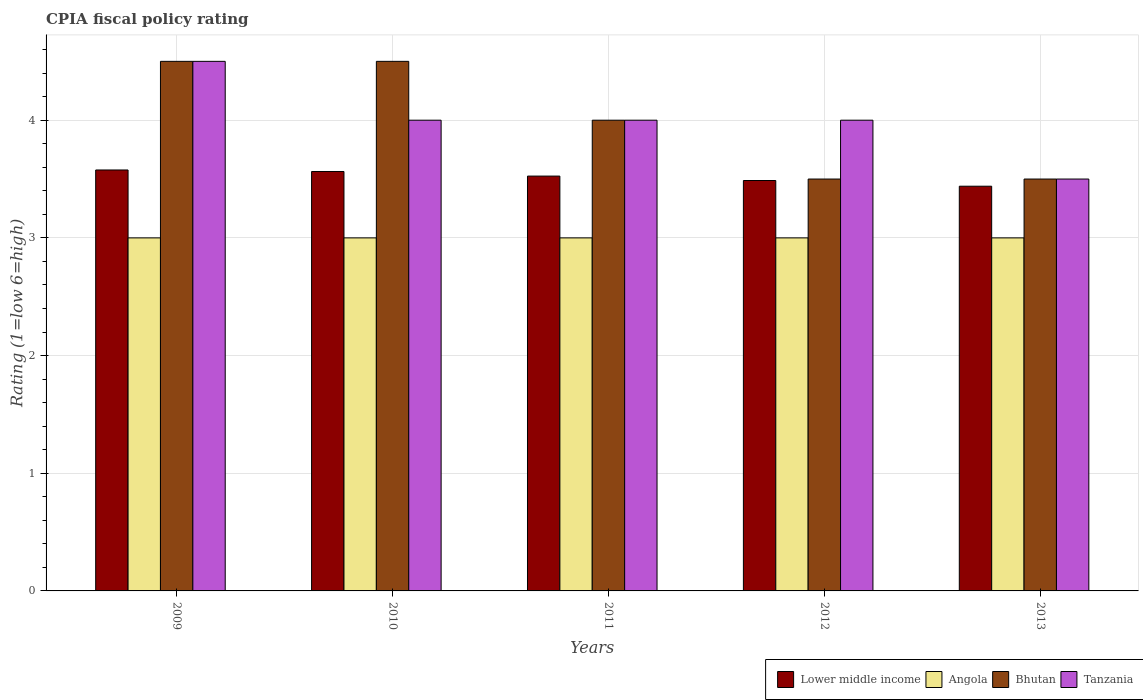Are the number of bars per tick equal to the number of legend labels?
Give a very brief answer. Yes. Are the number of bars on each tick of the X-axis equal?
Make the answer very short. Yes. How many bars are there on the 2nd tick from the right?
Offer a very short reply. 4. What is the label of the 2nd group of bars from the left?
Give a very brief answer. 2010. Across all years, what is the minimum CPIA rating in Lower middle income?
Give a very brief answer. 3.44. In which year was the CPIA rating in Angola maximum?
Offer a very short reply. 2009. What is the difference between the CPIA rating in Bhutan in 2009 and that in 2012?
Give a very brief answer. 1. What is the average CPIA rating in Bhutan per year?
Make the answer very short. 4. In the year 2013, what is the difference between the CPIA rating in Lower middle income and CPIA rating in Angola?
Your answer should be compact. 0.44. In how many years, is the CPIA rating in Angola greater than 1?
Ensure brevity in your answer.  5. Is the CPIA rating in Bhutan in 2009 less than that in 2012?
Provide a short and direct response. No. Is the difference between the CPIA rating in Lower middle income in 2010 and 2012 greater than the difference between the CPIA rating in Angola in 2010 and 2012?
Make the answer very short. Yes. What is the difference between the highest and the lowest CPIA rating in Angola?
Your response must be concise. 0. In how many years, is the CPIA rating in Lower middle income greater than the average CPIA rating in Lower middle income taken over all years?
Provide a succinct answer. 3. Is the sum of the CPIA rating in Tanzania in 2010 and 2013 greater than the maximum CPIA rating in Angola across all years?
Your answer should be compact. Yes. What does the 2nd bar from the left in 2012 represents?
Your answer should be very brief. Angola. What does the 2nd bar from the right in 2013 represents?
Provide a succinct answer. Bhutan. How many bars are there?
Keep it short and to the point. 20. How many years are there in the graph?
Offer a very short reply. 5. Are the values on the major ticks of Y-axis written in scientific E-notation?
Provide a short and direct response. No. Does the graph contain any zero values?
Ensure brevity in your answer.  No. Does the graph contain grids?
Give a very brief answer. Yes. Where does the legend appear in the graph?
Keep it short and to the point. Bottom right. How are the legend labels stacked?
Ensure brevity in your answer.  Horizontal. What is the title of the graph?
Your response must be concise. CPIA fiscal policy rating. What is the label or title of the X-axis?
Ensure brevity in your answer.  Years. What is the Rating (1=low 6=high) of Lower middle income in 2009?
Your answer should be very brief. 3.58. What is the Rating (1=low 6=high) in Angola in 2009?
Keep it short and to the point. 3. What is the Rating (1=low 6=high) of Bhutan in 2009?
Offer a very short reply. 4.5. What is the Rating (1=low 6=high) of Lower middle income in 2010?
Provide a short and direct response. 3.56. What is the Rating (1=low 6=high) of Angola in 2010?
Your answer should be compact. 3. What is the Rating (1=low 6=high) in Tanzania in 2010?
Provide a short and direct response. 4. What is the Rating (1=low 6=high) of Lower middle income in 2011?
Give a very brief answer. 3.52. What is the Rating (1=low 6=high) in Bhutan in 2011?
Provide a short and direct response. 4. What is the Rating (1=low 6=high) of Tanzania in 2011?
Provide a succinct answer. 4. What is the Rating (1=low 6=high) in Lower middle income in 2012?
Provide a succinct answer. 3.49. What is the Rating (1=low 6=high) in Bhutan in 2012?
Your answer should be very brief. 3.5. What is the Rating (1=low 6=high) in Lower middle income in 2013?
Provide a short and direct response. 3.44. What is the Rating (1=low 6=high) of Angola in 2013?
Provide a succinct answer. 3. What is the Rating (1=low 6=high) in Bhutan in 2013?
Your answer should be very brief. 3.5. Across all years, what is the maximum Rating (1=low 6=high) in Lower middle income?
Your answer should be very brief. 3.58. Across all years, what is the minimum Rating (1=low 6=high) in Lower middle income?
Offer a terse response. 3.44. Across all years, what is the minimum Rating (1=low 6=high) in Angola?
Your response must be concise. 3. Across all years, what is the minimum Rating (1=low 6=high) in Bhutan?
Ensure brevity in your answer.  3.5. What is the total Rating (1=low 6=high) of Lower middle income in the graph?
Your answer should be very brief. 17.59. What is the total Rating (1=low 6=high) of Bhutan in the graph?
Your answer should be very brief. 20. What is the total Rating (1=low 6=high) of Tanzania in the graph?
Your response must be concise. 20. What is the difference between the Rating (1=low 6=high) in Lower middle income in 2009 and that in 2010?
Your answer should be compact. 0.01. What is the difference between the Rating (1=low 6=high) in Angola in 2009 and that in 2010?
Ensure brevity in your answer.  0. What is the difference between the Rating (1=low 6=high) in Tanzania in 2009 and that in 2010?
Ensure brevity in your answer.  0.5. What is the difference between the Rating (1=low 6=high) in Lower middle income in 2009 and that in 2011?
Ensure brevity in your answer.  0.05. What is the difference between the Rating (1=low 6=high) of Angola in 2009 and that in 2011?
Your answer should be compact. 0. What is the difference between the Rating (1=low 6=high) of Tanzania in 2009 and that in 2011?
Provide a succinct answer. 0.5. What is the difference between the Rating (1=low 6=high) of Lower middle income in 2009 and that in 2012?
Ensure brevity in your answer.  0.09. What is the difference between the Rating (1=low 6=high) of Angola in 2009 and that in 2012?
Offer a very short reply. 0. What is the difference between the Rating (1=low 6=high) in Lower middle income in 2009 and that in 2013?
Provide a succinct answer. 0.14. What is the difference between the Rating (1=low 6=high) in Angola in 2009 and that in 2013?
Keep it short and to the point. 0. What is the difference between the Rating (1=low 6=high) in Bhutan in 2009 and that in 2013?
Give a very brief answer. 1. What is the difference between the Rating (1=low 6=high) in Lower middle income in 2010 and that in 2011?
Give a very brief answer. 0.04. What is the difference between the Rating (1=low 6=high) of Lower middle income in 2010 and that in 2012?
Offer a terse response. 0.08. What is the difference between the Rating (1=low 6=high) in Angola in 2010 and that in 2012?
Your response must be concise. 0. What is the difference between the Rating (1=low 6=high) of Bhutan in 2010 and that in 2012?
Provide a succinct answer. 1. What is the difference between the Rating (1=low 6=high) of Lower middle income in 2010 and that in 2013?
Offer a very short reply. 0.13. What is the difference between the Rating (1=low 6=high) in Angola in 2010 and that in 2013?
Make the answer very short. 0. What is the difference between the Rating (1=low 6=high) of Bhutan in 2010 and that in 2013?
Your answer should be compact. 1. What is the difference between the Rating (1=low 6=high) of Lower middle income in 2011 and that in 2012?
Your response must be concise. 0.04. What is the difference between the Rating (1=low 6=high) of Bhutan in 2011 and that in 2012?
Your answer should be very brief. 0.5. What is the difference between the Rating (1=low 6=high) in Tanzania in 2011 and that in 2012?
Your answer should be very brief. 0. What is the difference between the Rating (1=low 6=high) in Lower middle income in 2011 and that in 2013?
Give a very brief answer. 0.09. What is the difference between the Rating (1=low 6=high) of Angola in 2011 and that in 2013?
Keep it short and to the point. 0. What is the difference between the Rating (1=low 6=high) in Bhutan in 2011 and that in 2013?
Give a very brief answer. 0.5. What is the difference between the Rating (1=low 6=high) in Tanzania in 2011 and that in 2013?
Offer a terse response. 0.5. What is the difference between the Rating (1=low 6=high) of Lower middle income in 2012 and that in 2013?
Make the answer very short. 0.05. What is the difference between the Rating (1=low 6=high) of Bhutan in 2012 and that in 2013?
Provide a succinct answer. 0. What is the difference between the Rating (1=low 6=high) of Lower middle income in 2009 and the Rating (1=low 6=high) of Angola in 2010?
Provide a succinct answer. 0.58. What is the difference between the Rating (1=low 6=high) in Lower middle income in 2009 and the Rating (1=low 6=high) in Bhutan in 2010?
Offer a terse response. -0.92. What is the difference between the Rating (1=low 6=high) of Lower middle income in 2009 and the Rating (1=low 6=high) of Tanzania in 2010?
Ensure brevity in your answer.  -0.42. What is the difference between the Rating (1=low 6=high) in Angola in 2009 and the Rating (1=low 6=high) in Tanzania in 2010?
Offer a very short reply. -1. What is the difference between the Rating (1=low 6=high) in Bhutan in 2009 and the Rating (1=low 6=high) in Tanzania in 2010?
Your answer should be compact. 0.5. What is the difference between the Rating (1=low 6=high) of Lower middle income in 2009 and the Rating (1=low 6=high) of Angola in 2011?
Make the answer very short. 0.58. What is the difference between the Rating (1=low 6=high) of Lower middle income in 2009 and the Rating (1=low 6=high) of Bhutan in 2011?
Provide a short and direct response. -0.42. What is the difference between the Rating (1=low 6=high) of Lower middle income in 2009 and the Rating (1=low 6=high) of Tanzania in 2011?
Offer a terse response. -0.42. What is the difference between the Rating (1=low 6=high) in Angola in 2009 and the Rating (1=low 6=high) in Bhutan in 2011?
Give a very brief answer. -1. What is the difference between the Rating (1=low 6=high) of Angola in 2009 and the Rating (1=low 6=high) of Tanzania in 2011?
Offer a terse response. -1. What is the difference between the Rating (1=low 6=high) in Lower middle income in 2009 and the Rating (1=low 6=high) in Angola in 2012?
Your answer should be compact. 0.58. What is the difference between the Rating (1=low 6=high) of Lower middle income in 2009 and the Rating (1=low 6=high) of Bhutan in 2012?
Your answer should be compact. 0.08. What is the difference between the Rating (1=low 6=high) of Lower middle income in 2009 and the Rating (1=low 6=high) of Tanzania in 2012?
Your response must be concise. -0.42. What is the difference between the Rating (1=low 6=high) of Angola in 2009 and the Rating (1=low 6=high) of Bhutan in 2012?
Give a very brief answer. -0.5. What is the difference between the Rating (1=low 6=high) of Bhutan in 2009 and the Rating (1=low 6=high) of Tanzania in 2012?
Your answer should be compact. 0.5. What is the difference between the Rating (1=low 6=high) in Lower middle income in 2009 and the Rating (1=low 6=high) in Angola in 2013?
Provide a succinct answer. 0.58. What is the difference between the Rating (1=low 6=high) in Lower middle income in 2009 and the Rating (1=low 6=high) in Bhutan in 2013?
Give a very brief answer. 0.08. What is the difference between the Rating (1=low 6=high) in Lower middle income in 2009 and the Rating (1=low 6=high) in Tanzania in 2013?
Ensure brevity in your answer.  0.08. What is the difference between the Rating (1=low 6=high) of Angola in 2009 and the Rating (1=low 6=high) of Bhutan in 2013?
Make the answer very short. -0.5. What is the difference between the Rating (1=low 6=high) of Bhutan in 2009 and the Rating (1=low 6=high) of Tanzania in 2013?
Make the answer very short. 1. What is the difference between the Rating (1=low 6=high) in Lower middle income in 2010 and the Rating (1=low 6=high) in Angola in 2011?
Provide a short and direct response. 0.56. What is the difference between the Rating (1=low 6=high) in Lower middle income in 2010 and the Rating (1=low 6=high) in Bhutan in 2011?
Ensure brevity in your answer.  -0.44. What is the difference between the Rating (1=low 6=high) in Lower middle income in 2010 and the Rating (1=low 6=high) in Tanzania in 2011?
Provide a succinct answer. -0.44. What is the difference between the Rating (1=low 6=high) of Lower middle income in 2010 and the Rating (1=low 6=high) of Angola in 2012?
Provide a short and direct response. 0.56. What is the difference between the Rating (1=low 6=high) of Lower middle income in 2010 and the Rating (1=low 6=high) of Bhutan in 2012?
Keep it short and to the point. 0.06. What is the difference between the Rating (1=low 6=high) of Lower middle income in 2010 and the Rating (1=low 6=high) of Tanzania in 2012?
Give a very brief answer. -0.44. What is the difference between the Rating (1=low 6=high) in Angola in 2010 and the Rating (1=low 6=high) in Bhutan in 2012?
Keep it short and to the point. -0.5. What is the difference between the Rating (1=low 6=high) in Angola in 2010 and the Rating (1=low 6=high) in Tanzania in 2012?
Offer a very short reply. -1. What is the difference between the Rating (1=low 6=high) in Lower middle income in 2010 and the Rating (1=low 6=high) in Angola in 2013?
Your answer should be compact. 0.56. What is the difference between the Rating (1=low 6=high) in Lower middle income in 2010 and the Rating (1=low 6=high) in Bhutan in 2013?
Your answer should be compact. 0.06. What is the difference between the Rating (1=low 6=high) of Lower middle income in 2010 and the Rating (1=low 6=high) of Tanzania in 2013?
Give a very brief answer. 0.06. What is the difference between the Rating (1=low 6=high) of Bhutan in 2010 and the Rating (1=low 6=high) of Tanzania in 2013?
Ensure brevity in your answer.  1. What is the difference between the Rating (1=low 6=high) in Lower middle income in 2011 and the Rating (1=low 6=high) in Angola in 2012?
Make the answer very short. 0.53. What is the difference between the Rating (1=low 6=high) of Lower middle income in 2011 and the Rating (1=low 6=high) of Bhutan in 2012?
Your answer should be compact. 0.03. What is the difference between the Rating (1=low 6=high) of Lower middle income in 2011 and the Rating (1=low 6=high) of Tanzania in 2012?
Offer a terse response. -0.47. What is the difference between the Rating (1=low 6=high) of Angola in 2011 and the Rating (1=low 6=high) of Bhutan in 2012?
Provide a succinct answer. -0.5. What is the difference between the Rating (1=low 6=high) of Angola in 2011 and the Rating (1=low 6=high) of Tanzania in 2012?
Provide a succinct answer. -1. What is the difference between the Rating (1=low 6=high) in Bhutan in 2011 and the Rating (1=low 6=high) in Tanzania in 2012?
Ensure brevity in your answer.  0. What is the difference between the Rating (1=low 6=high) of Lower middle income in 2011 and the Rating (1=low 6=high) of Angola in 2013?
Ensure brevity in your answer.  0.53. What is the difference between the Rating (1=low 6=high) of Lower middle income in 2011 and the Rating (1=low 6=high) of Bhutan in 2013?
Offer a very short reply. 0.03. What is the difference between the Rating (1=low 6=high) of Lower middle income in 2011 and the Rating (1=low 6=high) of Tanzania in 2013?
Give a very brief answer. 0.03. What is the difference between the Rating (1=low 6=high) of Angola in 2011 and the Rating (1=low 6=high) of Bhutan in 2013?
Your response must be concise. -0.5. What is the difference between the Rating (1=low 6=high) of Angola in 2011 and the Rating (1=low 6=high) of Tanzania in 2013?
Give a very brief answer. -0.5. What is the difference between the Rating (1=low 6=high) of Bhutan in 2011 and the Rating (1=low 6=high) of Tanzania in 2013?
Give a very brief answer. 0.5. What is the difference between the Rating (1=low 6=high) of Lower middle income in 2012 and the Rating (1=low 6=high) of Angola in 2013?
Keep it short and to the point. 0.49. What is the difference between the Rating (1=low 6=high) of Lower middle income in 2012 and the Rating (1=low 6=high) of Bhutan in 2013?
Give a very brief answer. -0.01. What is the difference between the Rating (1=low 6=high) of Lower middle income in 2012 and the Rating (1=low 6=high) of Tanzania in 2013?
Your answer should be compact. -0.01. What is the difference between the Rating (1=low 6=high) in Angola in 2012 and the Rating (1=low 6=high) in Bhutan in 2013?
Provide a short and direct response. -0.5. What is the difference between the Rating (1=low 6=high) in Angola in 2012 and the Rating (1=low 6=high) in Tanzania in 2013?
Offer a very short reply. -0.5. What is the difference between the Rating (1=low 6=high) of Bhutan in 2012 and the Rating (1=low 6=high) of Tanzania in 2013?
Your answer should be very brief. 0. What is the average Rating (1=low 6=high) of Lower middle income per year?
Offer a terse response. 3.52. What is the average Rating (1=low 6=high) in Bhutan per year?
Your answer should be compact. 4. In the year 2009, what is the difference between the Rating (1=low 6=high) of Lower middle income and Rating (1=low 6=high) of Angola?
Give a very brief answer. 0.58. In the year 2009, what is the difference between the Rating (1=low 6=high) in Lower middle income and Rating (1=low 6=high) in Bhutan?
Your response must be concise. -0.92. In the year 2009, what is the difference between the Rating (1=low 6=high) in Lower middle income and Rating (1=low 6=high) in Tanzania?
Offer a terse response. -0.92. In the year 2009, what is the difference between the Rating (1=low 6=high) of Angola and Rating (1=low 6=high) of Tanzania?
Keep it short and to the point. -1.5. In the year 2009, what is the difference between the Rating (1=low 6=high) of Bhutan and Rating (1=low 6=high) of Tanzania?
Offer a very short reply. 0. In the year 2010, what is the difference between the Rating (1=low 6=high) of Lower middle income and Rating (1=low 6=high) of Angola?
Offer a terse response. 0.56. In the year 2010, what is the difference between the Rating (1=low 6=high) of Lower middle income and Rating (1=low 6=high) of Bhutan?
Keep it short and to the point. -0.94. In the year 2010, what is the difference between the Rating (1=low 6=high) of Lower middle income and Rating (1=low 6=high) of Tanzania?
Provide a short and direct response. -0.44. In the year 2011, what is the difference between the Rating (1=low 6=high) of Lower middle income and Rating (1=low 6=high) of Angola?
Your answer should be compact. 0.53. In the year 2011, what is the difference between the Rating (1=low 6=high) in Lower middle income and Rating (1=low 6=high) in Bhutan?
Offer a terse response. -0.47. In the year 2011, what is the difference between the Rating (1=low 6=high) of Lower middle income and Rating (1=low 6=high) of Tanzania?
Your response must be concise. -0.47. In the year 2011, what is the difference between the Rating (1=low 6=high) of Angola and Rating (1=low 6=high) of Bhutan?
Give a very brief answer. -1. In the year 2011, what is the difference between the Rating (1=low 6=high) of Bhutan and Rating (1=low 6=high) of Tanzania?
Your answer should be very brief. 0. In the year 2012, what is the difference between the Rating (1=low 6=high) of Lower middle income and Rating (1=low 6=high) of Angola?
Ensure brevity in your answer.  0.49. In the year 2012, what is the difference between the Rating (1=low 6=high) of Lower middle income and Rating (1=low 6=high) of Bhutan?
Keep it short and to the point. -0.01. In the year 2012, what is the difference between the Rating (1=low 6=high) in Lower middle income and Rating (1=low 6=high) in Tanzania?
Ensure brevity in your answer.  -0.51. In the year 2012, what is the difference between the Rating (1=low 6=high) in Angola and Rating (1=low 6=high) in Bhutan?
Make the answer very short. -0.5. In the year 2012, what is the difference between the Rating (1=low 6=high) of Bhutan and Rating (1=low 6=high) of Tanzania?
Your answer should be compact. -0.5. In the year 2013, what is the difference between the Rating (1=low 6=high) of Lower middle income and Rating (1=low 6=high) of Angola?
Your response must be concise. 0.44. In the year 2013, what is the difference between the Rating (1=low 6=high) of Lower middle income and Rating (1=low 6=high) of Bhutan?
Keep it short and to the point. -0.06. In the year 2013, what is the difference between the Rating (1=low 6=high) in Lower middle income and Rating (1=low 6=high) in Tanzania?
Your response must be concise. -0.06. In the year 2013, what is the difference between the Rating (1=low 6=high) in Angola and Rating (1=low 6=high) in Bhutan?
Provide a succinct answer. -0.5. What is the ratio of the Rating (1=low 6=high) of Angola in 2009 to that in 2010?
Your answer should be very brief. 1. What is the ratio of the Rating (1=low 6=high) of Lower middle income in 2009 to that in 2011?
Ensure brevity in your answer.  1.01. What is the ratio of the Rating (1=low 6=high) of Bhutan in 2009 to that in 2011?
Make the answer very short. 1.12. What is the ratio of the Rating (1=low 6=high) of Lower middle income in 2009 to that in 2012?
Provide a short and direct response. 1.03. What is the ratio of the Rating (1=low 6=high) in Tanzania in 2009 to that in 2012?
Offer a terse response. 1.12. What is the ratio of the Rating (1=low 6=high) in Lower middle income in 2009 to that in 2013?
Your answer should be compact. 1.04. What is the ratio of the Rating (1=low 6=high) of Bhutan in 2009 to that in 2013?
Your answer should be compact. 1.29. What is the ratio of the Rating (1=low 6=high) in Tanzania in 2009 to that in 2013?
Your response must be concise. 1.29. What is the ratio of the Rating (1=low 6=high) of Lower middle income in 2010 to that in 2011?
Make the answer very short. 1.01. What is the ratio of the Rating (1=low 6=high) in Angola in 2010 to that in 2011?
Give a very brief answer. 1. What is the ratio of the Rating (1=low 6=high) in Angola in 2010 to that in 2012?
Your answer should be very brief. 1. What is the ratio of the Rating (1=low 6=high) of Tanzania in 2010 to that in 2012?
Provide a succinct answer. 1. What is the ratio of the Rating (1=low 6=high) of Lower middle income in 2010 to that in 2013?
Your response must be concise. 1.04. What is the ratio of the Rating (1=low 6=high) in Bhutan in 2010 to that in 2013?
Your answer should be compact. 1.29. What is the ratio of the Rating (1=low 6=high) of Lower middle income in 2011 to that in 2012?
Your answer should be very brief. 1.01. What is the ratio of the Rating (1=low 6=high) in Angola in 2011 to that in 2012?
Ensure brevity in your answer.  1. What is the ratio of the Rating (1=low 6=high) in Bhutan in 2011 to that in 2012?
Offer a very short reply. 1.14. What is the ratio of the Rating (1=low 6=high) in Tanzania in 2011 to that in 2012?
Your answer should be very brief. 1. What is the ratio of the Rating (1=low 6=high) of Lower middle income in 2011 to that in 2013?
Your answer should be compact. 1.02. What is the ratio of the Rating (1=low 6=high) in Bhutan in 2011 to that in 2013?
Your response must be concise. 1.14. What is the ratio of the Rating (1=low 6=high) of Lower middle income in 2012 to that in 2013?
Make the answer very short. 1.01. What is the ratio of the Rating (1=low 6=high) in Angola in 2012 to that in 2013?
Give a very brief answer. 1. What is the ratio of the Rating (1=low 6=high) of Bhutan in 2012 to that in 2013?
Offer a terse response. 1. What is the difference between the highest and the second highest Rating (1=low 6=high) in Lower middle income?
Make the answer very short. 0.01. What is the difference between the highest and the second highest Rating (1=low 6=high) of Angola?
Your answer should be very brief. 0. What is the difference between the highest and the second highest Rating (1=low 6=high) of Bhutan?
Ensure brevity in your answer.  0. What is the difference between the highest and the second highest Rating (1=low 6=high) in Tanzania?
Make the answer very short. 0.5. What is the difference between the highest and the lowest Rating (1=low 6=high) in Lower middle income?
Your answer should be very brief. 0.14. What is the difference between the highest and the lowest Rating (1=low 6=high) in Bhutan?
Ensure brevity in your answer.  1. What is the difference between the highest and the lowest Rating (1=low 6=high) in Tanzania?
Provide a succinct answer. 1. 